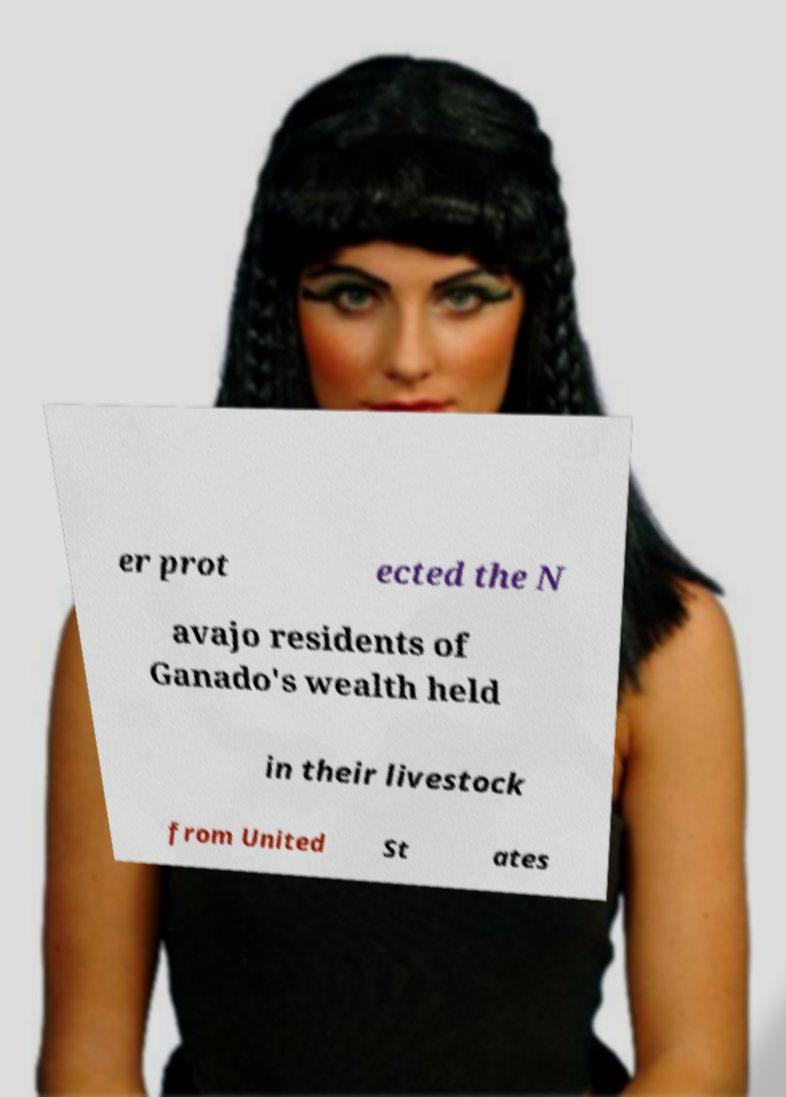I need the written content from this picture converted into text. Can you do that? er prot ected the N avajo residents of Ganado's wealth held in their livestock from United St ates 